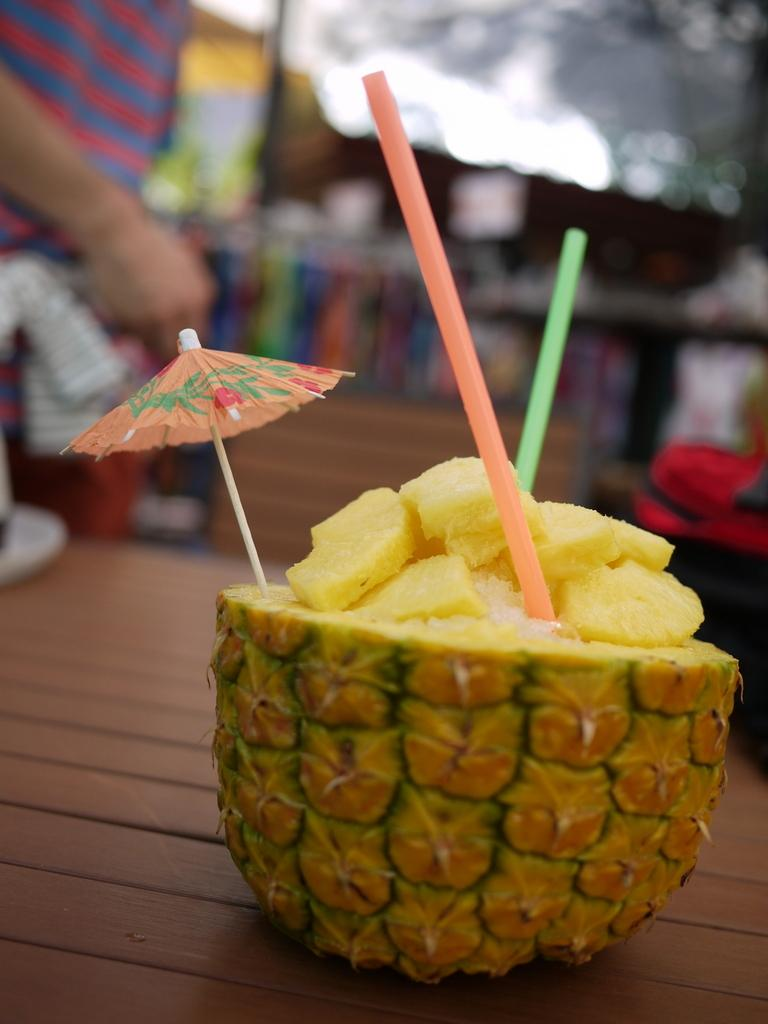What is the main object in the picture? There is a pineapple in the picture. What is unique about the pineapple? The pineapple has straws on it. What is the pineapple placed on? The pineapple is on a wooden surface. Can you describe the background of the image? The background of the image is blurred, and there is a person in the background. What time of day is the meeting taking place in the image? There is no meeting present in the image, and therefore no specific time of day can be determined. 